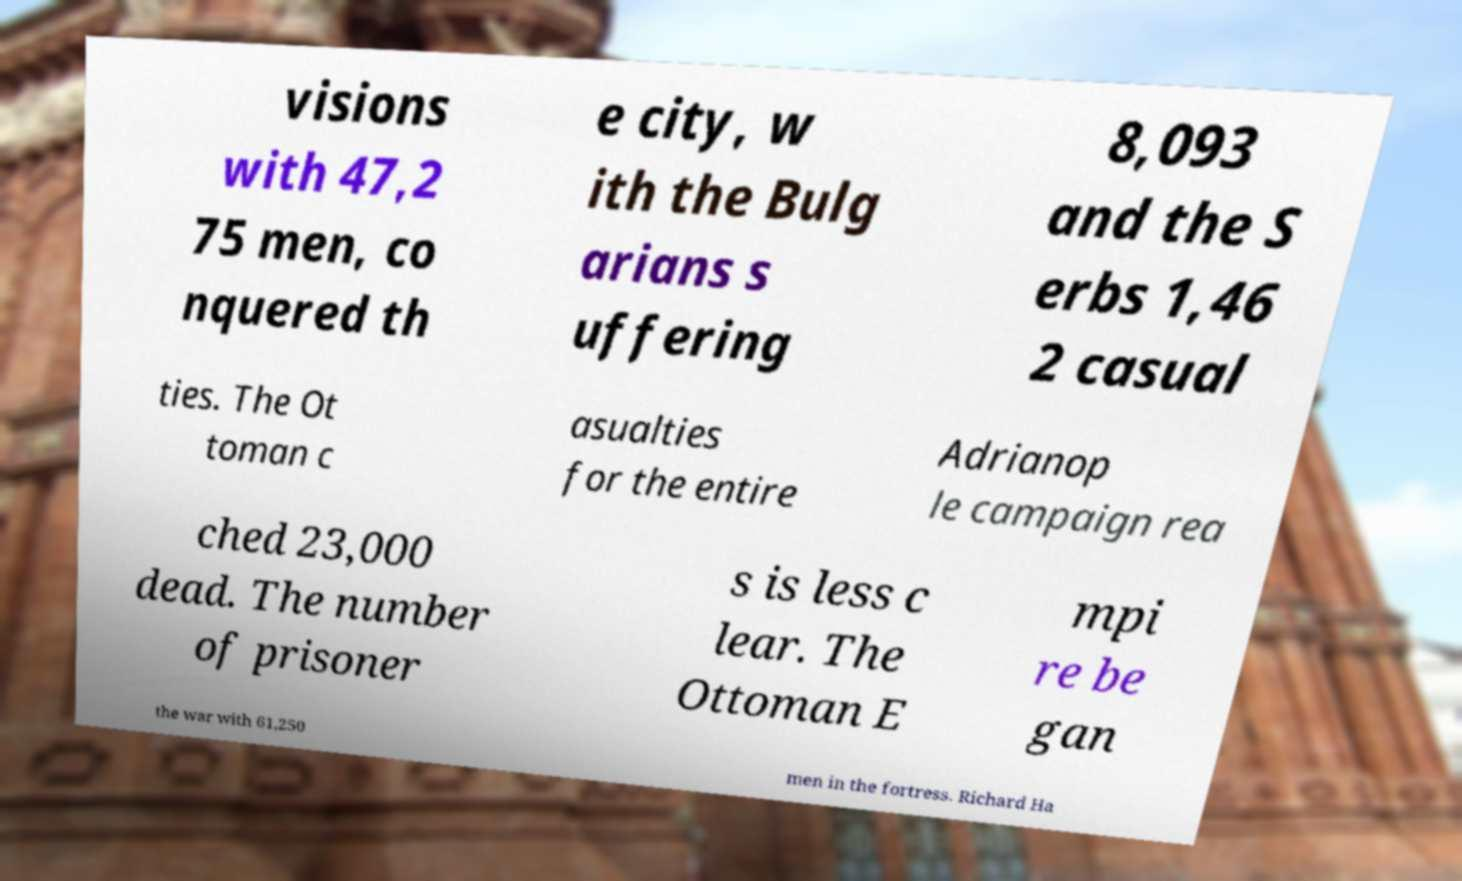Could you extract and type out the text from this image? visions with 47,2 75 men, co nquered th e city, w ith the Bulg arians s uffering 8,093 and the S erbs 1,46 2 casual ties. The Ot toman c asualties for the entire Adrianop le campaign rea ched 23,000 dead. The number of prisoner s is less c lear. The Ottoman E mpi re be gan the war with 61,250 men in the fortress. Richard Ha 